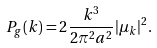Convert formula to latex. <formula><loc_0><loc_0><loc_500><loc_500>P _ { g } ( k ) = 2 \frac { k ^ { 3 } } { 2 \pi ^ { 2 } a ^ { 2 } } | \mu _ { k } | ^ { 2 } .</formula> 